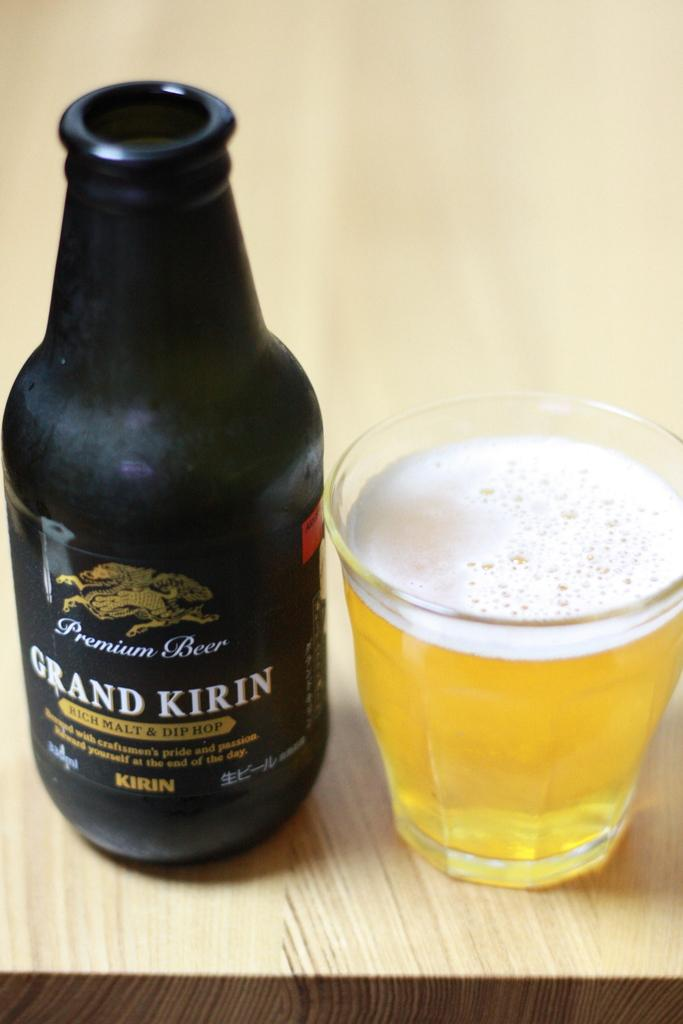<image>
Give a short and clear explanation of the subsequent image. A bottle of Grand Kirin premium beer next to a glass of beer. 